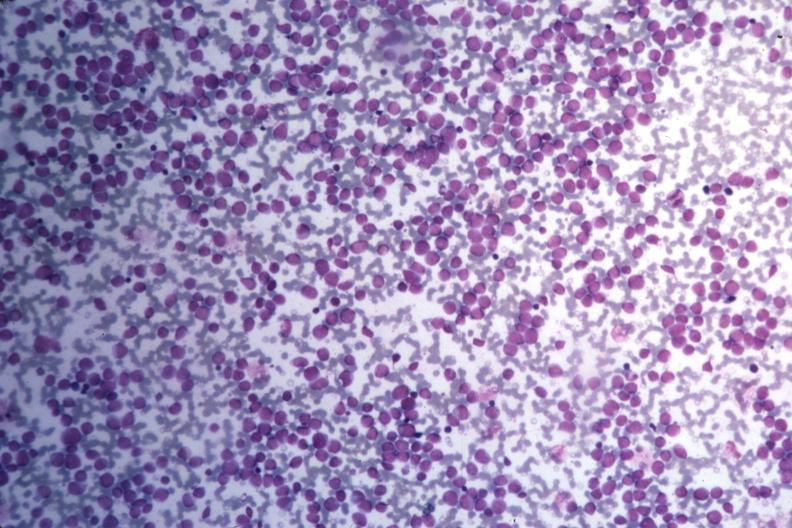what is present?
Answer the question using a single word or phrase. Hematologic 